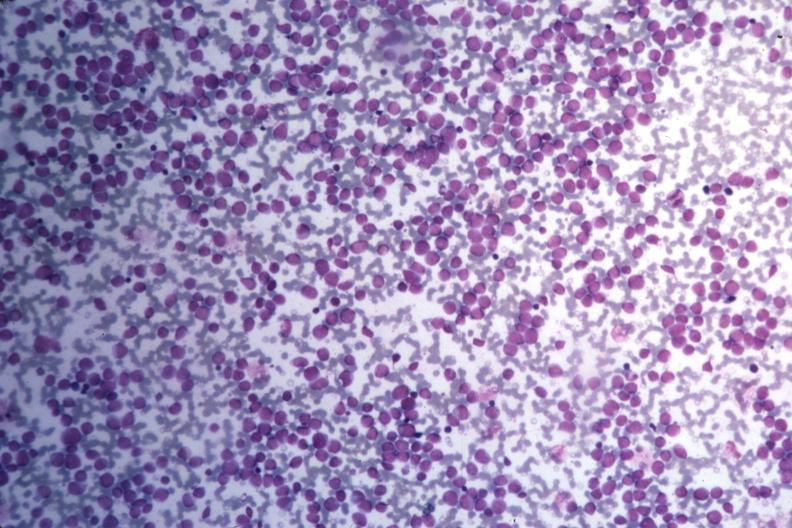what is present?
Answer the question using a single word or phrase. Hematologic 